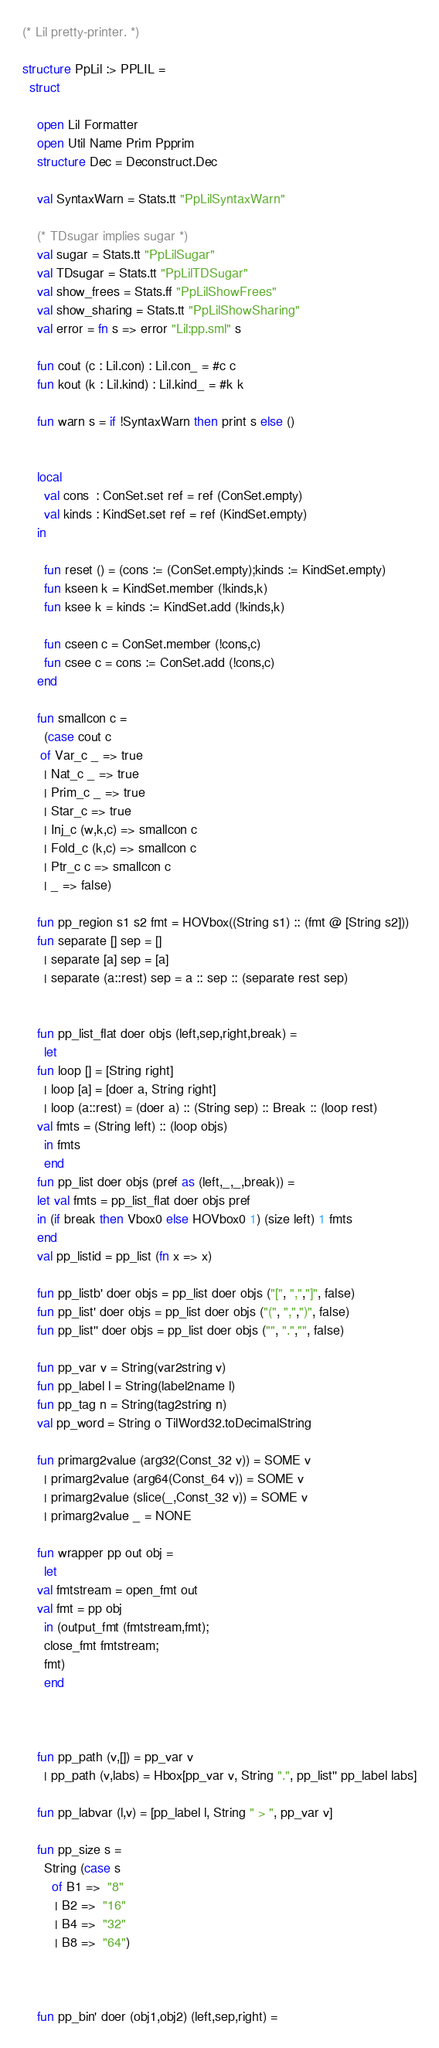Convert code to text. <code><loc_0><loc_0><loc_500><loc_500><_SML_>(* Lil pretty-printer. *)

structure PpLil :> PPLIL =
  struct

    open Lil Formatter
    open Util Name Prim Ppprim
    structure Dec = Deconstruct.Dec

    val SyntaxWarn = Stats.tt "PpLilSyntaxWarn"

    (* TDsugar implies sugar *)
    val sugar = Stats.tt "PpLilSugar"
    val TDsugar = Stats.tt "PpLilTDSugar"
    val show_frees = Stats.ff "PpLilShowFrees"
    val show_sharing = Stats.tt "PpLilShowSharing"
    val error = fn s => error "Lil:pp.sml" s

    fun cout (c : Lil.con) : Lil.con_ = #c c
    fun kout (k : Lil.kind) : Lil.kind_ = #k k

    fun warn s = if !SyntaxWarn then print s else ()


    local
      val cons  : ConSet.set ref = ref (ConSet.empty)
      val kinds : KindSet.set ref = ref (KindSet.empty)
    in
      
      fun reset () = (cons := (ConSet.empty);kinds := KindSet.empty)
      fun kseen k = KindSet.member (!kinds,k)
      fun ksee k = kinds := KindSet.add (!kinds,k)

      fun cseen c = ConSet.member (!cons,c)
      fun csee c = cons := ConSet.add (!cons,c)
    end

    fun smallcon c = 
      (case cout c
	 of Var_c _ => true
	  | Nat_c _ => true
	  | Prim_c _ => true
	  | Star_c => true
	  | Inj_c (w,k,c) => smallcon c
	  | Fold_c (k,c) => smallcon c
	  | Ptr_c c => smallcon c
	  | _ => false)

    fun pp_region s1 s2 fmt = HOVbox((String s1) :: (fmt @ [String s2]))
    fun separate [] sep = []
      | separate [a] sep = [a]
      | separate (a::rest) sep = a :: sep :: (separate rest sep)


    fun pp_list_flat doer objs (left,sep,right,break) = 
      let 
	fun loop [] = [String right]
	  | loop [a] = [doer a, String right]
	  | loop (a::rest) = (doer a) :: (String sep) :: Break :: (loop rest)
	val fmts = (String left) :: (loop objs)
      in fmts
      end
    fun pp_list doer objs (pref as (left,_,_,break)) = 
	let val fmts = pp_list_flat doer objs pref
	in (if break then Vbox0 else HOVbox0 1) (size left) 1 fmts
	end
    val pp_listid = pp_list (fn x => x)

    fun pp_listb' doer objs = pp_list doer objs ("[", ",","]", false)
    fun pp_list' doer objs = pp_list doer objs ("(", ",",")", false)
    fun pp_list'' doer objs = pp_list doer objs ("", ".","", false)

    fun pp_var v = String(var2string v)
    fun pp_label l = String(label2name l)
    fun pp_tag n = String(tag2string n)
    val pp_word = String o TilWord32.toDecimalString
      
    fun primarg2value (arg32(Const_32 v)) = SOME v
      | primarg2value (arg64(Const_64 v)) = SOME v
      | primarg2value (slice(_,Const_32 v)) = SOME v
      | primarg2value _ = NONE

    fun wrapper pp out obj = 
      let 
	val fmtstream = open_fmt out
	val fmt = pp obj
      in (output_fmt (fmtstream,fmt); 
	  close_fmt fmtstream;
	  fmt)
      end



    fun pp_path (v,[]) = pp_var v
      | pp_path (v,labs) = Hbox[pp_var v, String ".", pp_list'' pp_label labs]

    fun pp_labvar (l,v) = [pp_label l, String " > ", pp_var v]

    fun pp_size s = 
      String (case s
		of B1 =>  "8"
		 | B2 =>  "16"
		 | B4 =>  "32"
		 | B8 =>  "64")



    fun pp_bin' doer (obj1,obj2) (left,sep,right) = </code> 